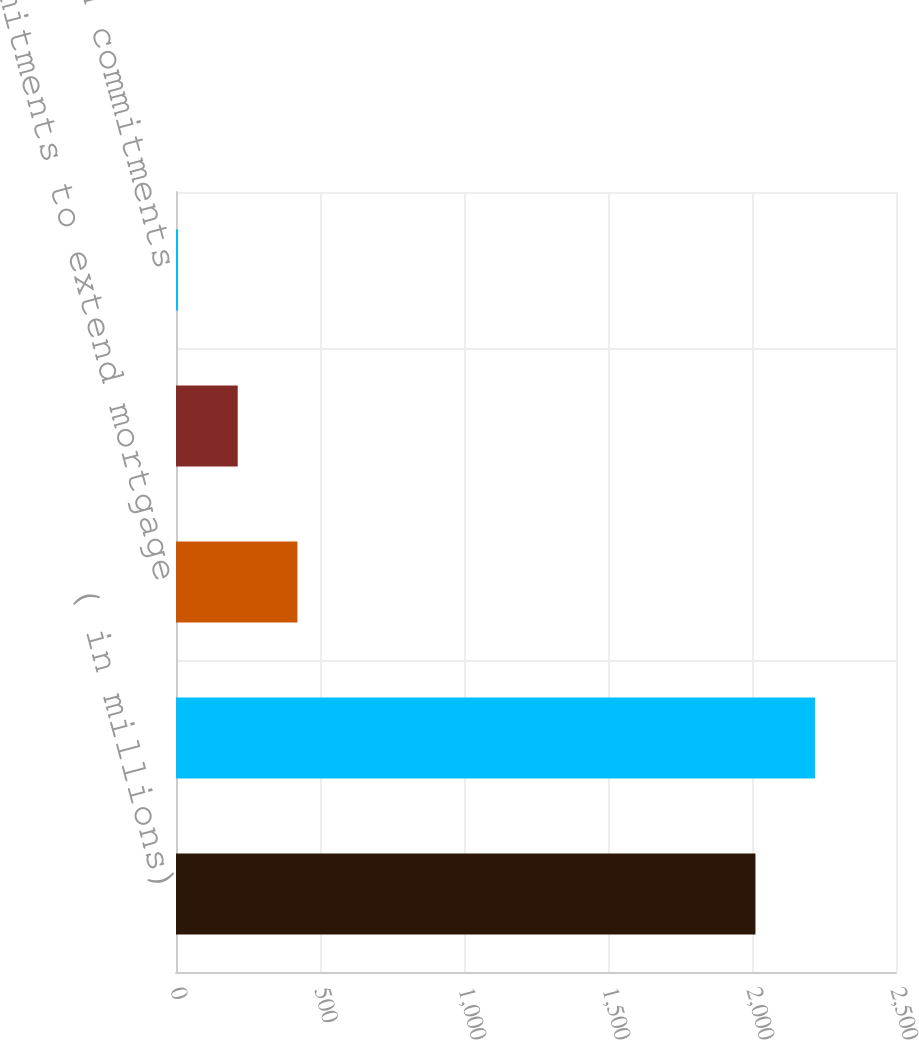Convert chart to OTSL. <chart><loc_0><loc_0><loc_500><loc_500><bar_chart><fcel>( in millions)<fcel>Commitments to invest in<fcel>Commitments to extend mortgage<fcel>Private placement commitments<fcel>Other loan commitments<nl><fcel>2012<fcel>2219.3<fcel>421.6<fcel>214.3<fcel>7<nl></chart> 